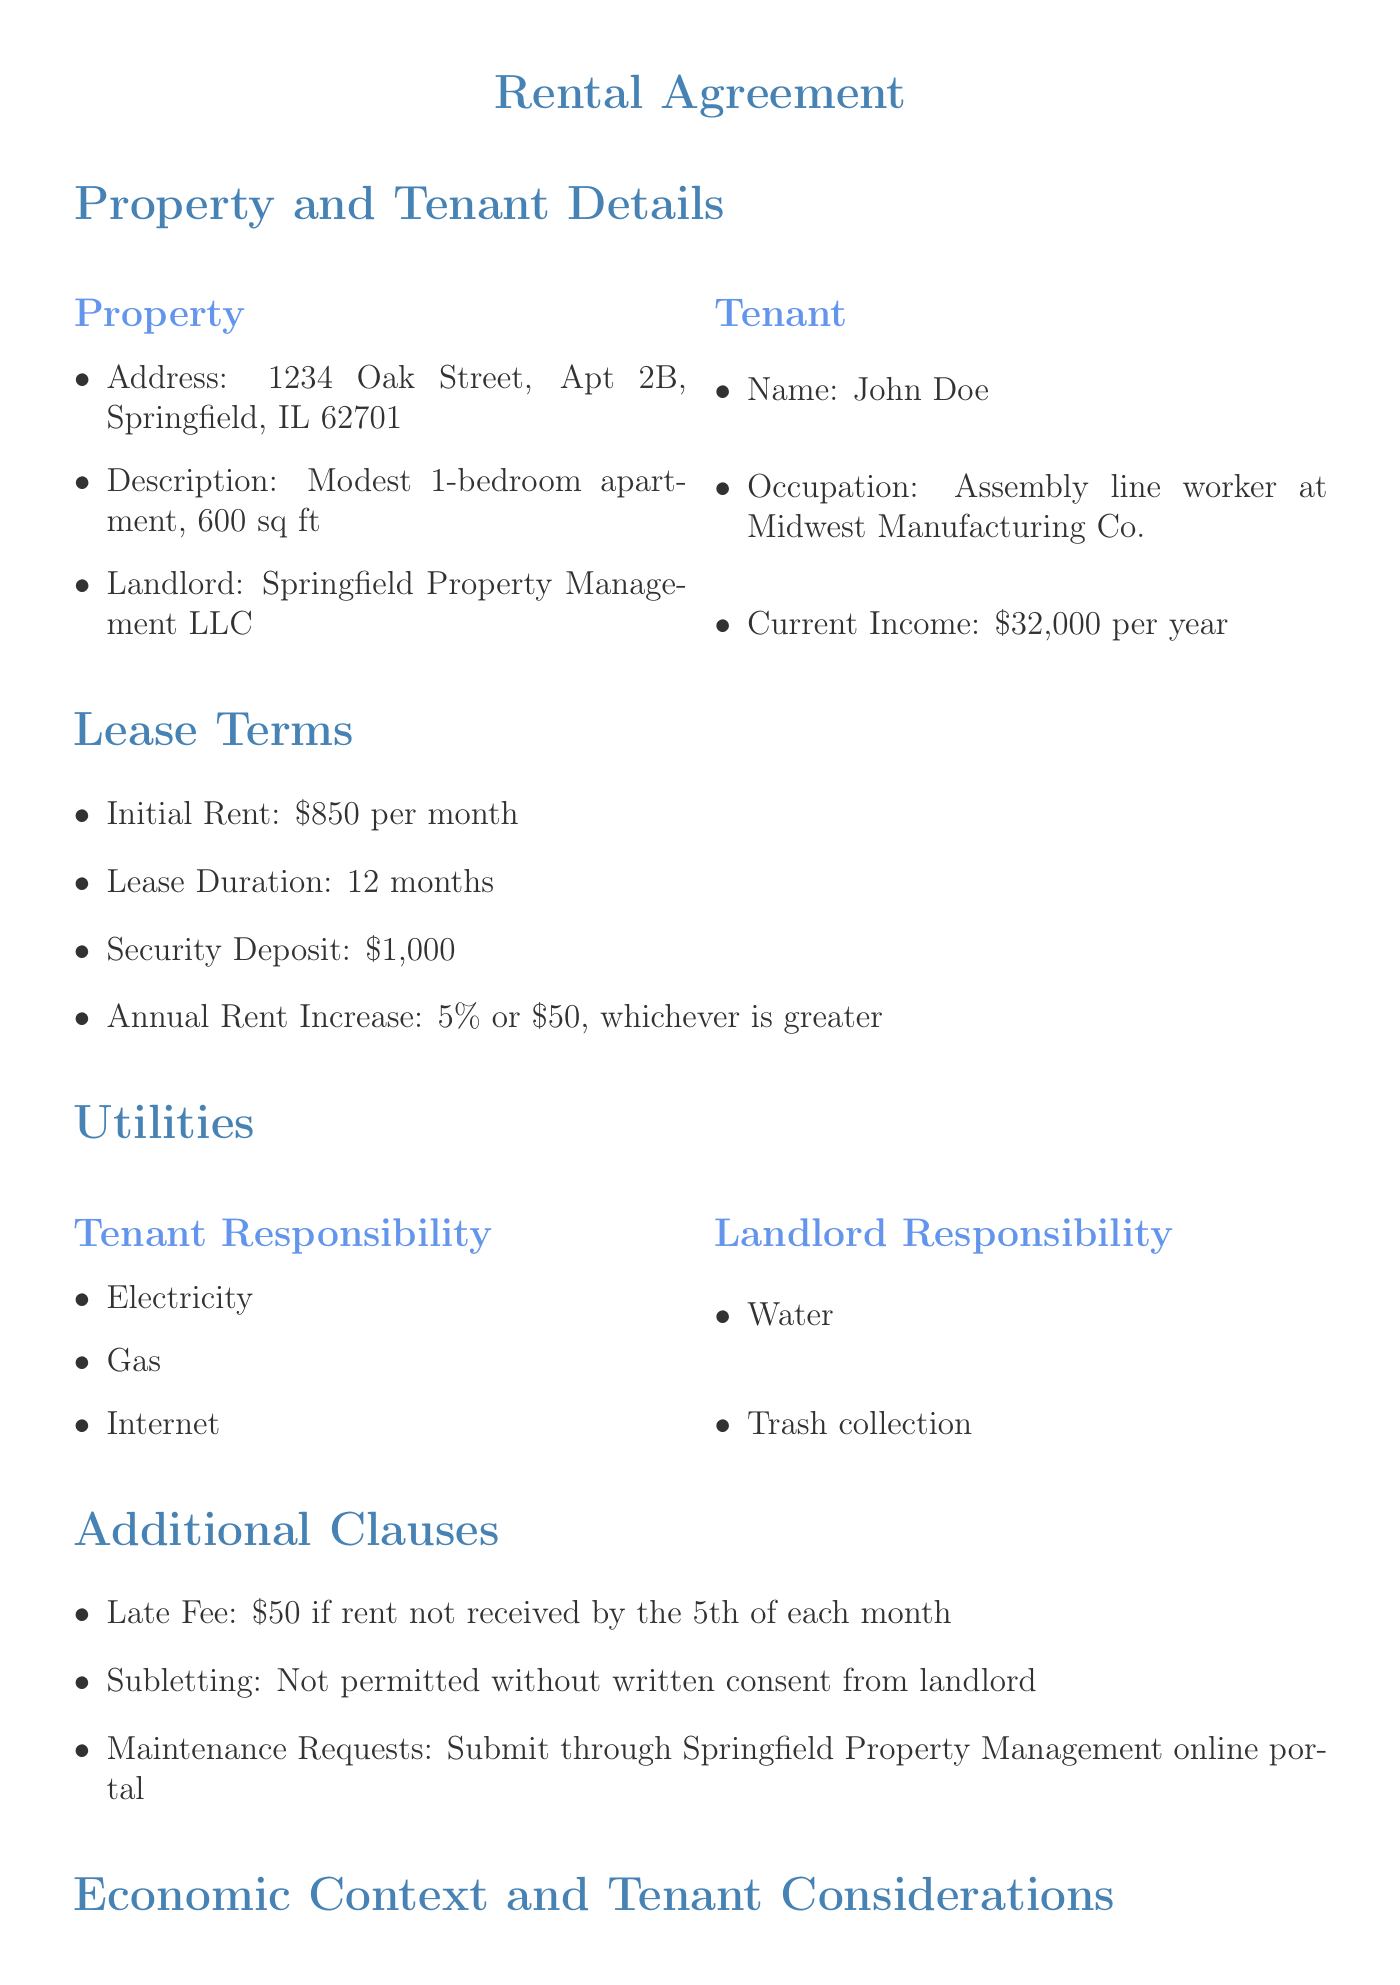What is the initial rent? The initial rent is specified in the lease terms section of the document.
Answer: $850 per month What is the average annual wage increase in the manufacturing sector? This information can be found in the local economic context section discussing wage changes.
Answer: 2.1% What is the security deposit amount? The security deposit is detailed under the lease terms in the rental agreement.
Answer: $1,000 What is the projected rent in three years? The projected rent is calculated based on the annual rent increases indicated in the tenant financial considerations section.
Answer: $984 per month What utilities are the tenant responsible for? The tenant responsibilities for utilities are listed in the utilities section of the document.
Answer: Electricity, Gas, Internet What is the late fee for unpaid rent? The late fee is mentioned in the additional clauses section of the rental agreement concerning rent payment.
Answer: $50 Is subletting allowed? The conditions regarding subletting are stated in the additional clauses section to inform the tenant.
Answer: Not permitted without written consent Where can maintenance requests be submitted? The information on where to submit maintenance requests is included in the additional clauses section.
Answer: Springfield Property Management online portal What local affordable housing programs are mentioned? The affordable housing programs available to tenants are provided in the tenant financial considerations section.
Answer: Springfield Housing Authority, Illinois Rental Assistance Program 